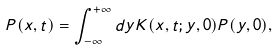Convert formula to latex. <formula><loc_0><loc_0><loc_500><loc_500>P ( x , t ) = \int _ { - \infty } ^ { + \infty } d y K ( x , t ; y , 0 ) P ( y , 0 ) ,</formula> 